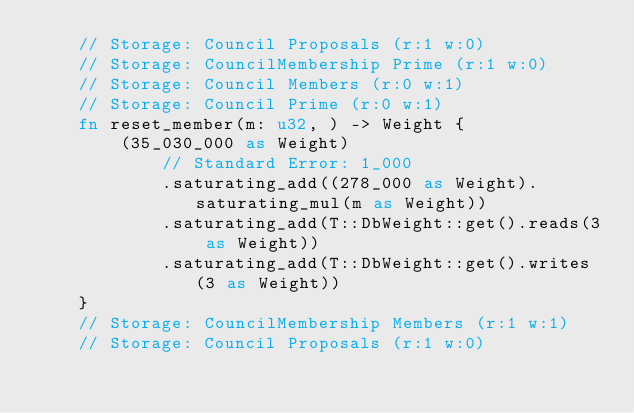<code> <loc_0><loc_0><loc_500><loc_500><_Rust_>	// Storage: Council Proposals (r:1 w:0)
	// Storage: CouncilMembership Prime (r:1 w:0)
	// Storage: Council Members (r:0 w:1)
	// Storage: Council Prime (r:0 w:1)
	fn reset_member(m: u32, ) -> Weight {
		(35_030_000 as Weight)
			// Standard Error: 1_000
			.saturating_add((278_000 as Weight).saturating_mul(m as Weight))
			.saturating_add(T::DbWeight::get().reads(3 as Weight))
			.saturating_add(T::DbWeight::get().writes(3 as Weight))
	}
	// Storage: CouncilMembership Members (r:1 w:1)
	// Storage: Council Proposals (r:1 w:0)</code> 